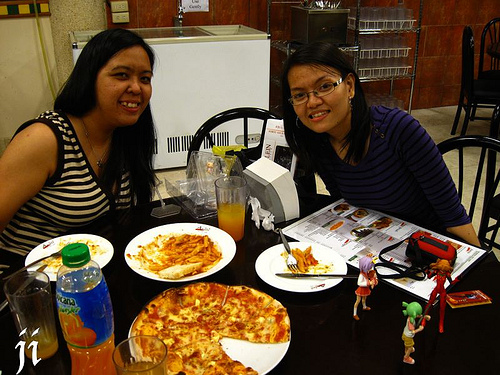Please transcribe the text information in this image. ji cana 